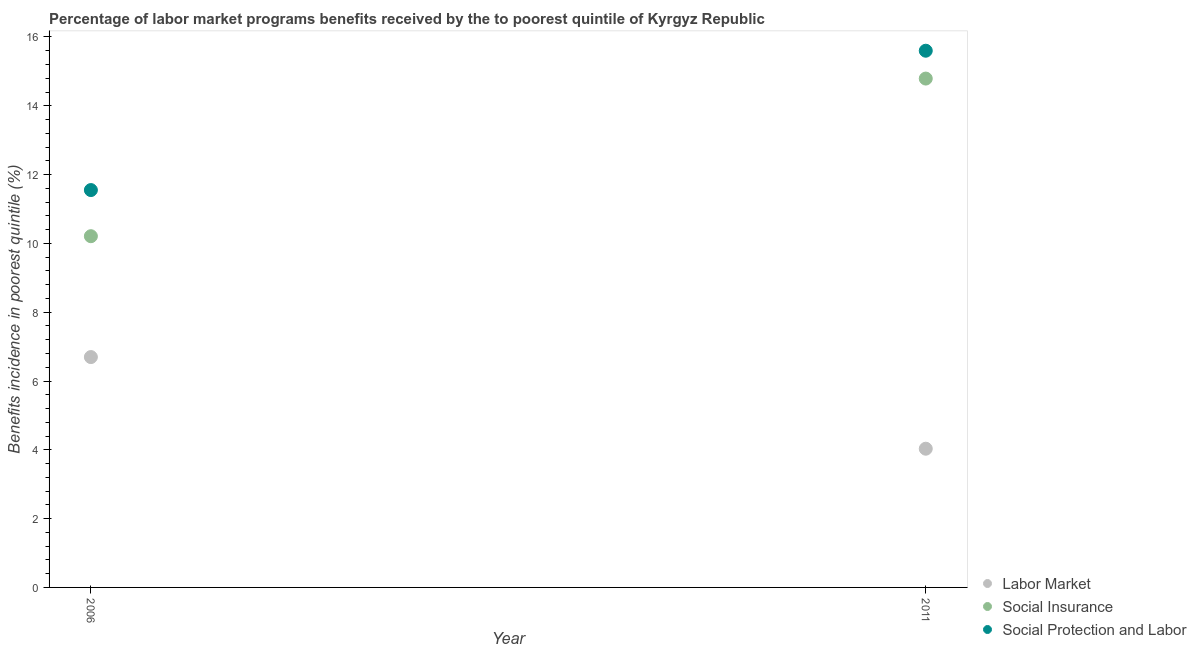What is the percentage of benefits received due to labor market programs in 2011?
Your response must be concise. 4.03. Across all years, what is the maximum percentage of benefits received due to social protection programs?
Offer a very short reply. 15.6. Across all years, what is the minimum percentage of benefits received due to labor market programs?
Make the answer very short. 4.03. In which year was the percentage of benefits received due to labor market programs maximum?
Make the answer very short. 2006. What is the total percentage of benefits received due to labor market programs in the graph?
Provide a succinct answer. 10.73. What is the difference between the percentage of benefits received due to labor market programs in 2006 and that in 2011?
Your response must be concise. 2.66. What is the difference between the percentage of benefits received due to social insurance programs in 2011 and the percentage of benefits received due to social protection programs in 2006?
Offer a very short reply. 3.24. What is the average percentage of benefits received due to labor market programs per year?
Keep it short and to the point. 5.36. In the year 2006, what is the difference between the percentage of benefits received due to labor market programs and percentage of benefits received due to social insurance programs?
Offer a terse response. -3.51. What is the ratio of the percentage of benefits received due to labor market programs in 2006 to that in 2011?
Provide a short and direct response. 1.66. Does the percentage of benefits received due to social insurance programs monotonically increase over the years?
Your response must be concise. Yes. Is the percentage of benefits received due to social insurance programs strictly greater than the percentage of benefits received due to social protection programs over the years?
Provide a short and direct response. No. Is the percentage of benefits received due to labor market programs strictly less than the percentage of benefits received due to social protection programs over the years?
Your response must be concise. Yes. How many dotlines are there?
Keep it short and to the point. 3. How many years are there in the graph?
Your response must be concise. 2. Are the values on the major ticks of Y-axis written in scientific E-notation?
Offer a very short reply. No. Does the graph contain any zero values?
Keep it short and to the point. No. Does the graph contain grids?
Offer a terse response. No. How many legend labels are there?
Your answer should be very brief. 3. What is the title of the graph?
Offer a terse response. Percentage of labor market programs benefits received by the to poorest quintile of Kyrgyz Republic. What is the label or title of the Y-axis?
Make the answer very short. Benefits incidence in poorest quintile (%). What is the Benefits incidence in poorest quintile (%) of Labor Market in 2006?
Make the answer very short. 6.7. What is the Benefits incidence in poorest quintile (%) of Social Insurance in 2006?
Your answer should be compact. 10.21. What is the Benefits incidence in poorest quintile (%) of Social Protection and Labor in 2006?
Provide a short and direct response. 11.55. What is the Benefits incidence in poorest quintile (%) of Labor Market in 2011?
Provide a short and direct response. 4.03. What is the Benefits incidence in poorest quintile (%) in Social Insurance in 2011?
Offer a terse response. 14.79. What is the Benefits incidence in poorest quintile (%) of Social Protection and Labor in 2011?
Give a very brief answer. 15.6. Across all years, what is the maximum Benefits incidence in poorest quintile (%) in Labor Market?
Keep it short and to the point. 6.7. Across all years, what is the maximum Benefits incidence in poorest quintile (%) of Social Insurance?
Make the answer very short. 14.79. Across all years, what is the maximum Benefits incidence in poorest quintile (%) in Social Protection and Labor?
Provide a succinct answer. 15.6. Across all years, what is the minimum Benefits incidence in poorest quintile (%) in Labor Market?
Your answer should be compact. 4.03. Across all years, what is the minimum Benefits incidence in poorest quintile (%) in Social Insurance?
Give a very brief answer. 10.21. Across all years, what is the minimum Benefits incidence in poorest quintile (%) in Social Protection and Labor?
Your answer should be compact. 11.55. What is the total Benefits incidence in poorest quintile (%) of Labor Market in the graph?
Provide a succinct answer. 10.73. What is the total Benefits incidence in poorest quintile (%) in Social Insurance in the graph?
Your answer should be very brief. 25. What is the total Benefits incidence in poorest quintile (%) in Social Protection and Labor in the graph?
Give a very brief answer. 27.15. What is the difference between the Benefits incidence in poorest quintile (%) in Labor Market in 2006 and that in 2011?
Provide a succinct answer. 2.66. What is the difference between the Benefits incidence in poorest quintile (%) in Social Insurance in 2006 and that in 2011?
Offer a very short reply. -4.58. What is the difference between the Benefits incidence in poorest quintile (%) of Social Protection and Labor in 2006 and that in 2011?
Your answer should be very brief. -4.05. What is the difference between the Benefits incidence in poorest quintile (%) of Labor Market in 2006 and the Benefits incidence in poorest quintile (%) of Social Insurance in 2011?
Your answer should be very brief. -8.09. What is the difference between the Benefits incidence in poorest quintile (%) in Labor Market in 2006 and the Benefits incidence in poorest quintile (%) in Social Protection and Labor in 2011?
Offer a very short reply. -8.9. What is the difference between the Benefits incidence in poorest quintile (%) of Social Insurance in 2006 and the Benefits incidence in poorest quintile (%) of Social Protection and Labor in 2011?
Offer a very short reply. -5.39. What is the average Benefits incidence in poorest quintile (%) of Labor Market per year?
Ensure brevity in your answer.  5.36. What is the average Benefits incidence in poorest quintile (%) in Social Insurance per year?
Give a very brief answer. 12.5. What is the average Benefits incidence in poorest quintile (%) in Social Protection and Labor per year?
Ensure brevity in your answer.  13.57. In the year 2006, what is the difference between the Benefits incidence in poorest quintile (%) in Labor Market and Benefits incidence in poorest quintile (%) in Social Insurance?
Offer a terse response. -3.51. In the year 2006, what is the difference between the Benefits incidence in poorest quintile (%) of Labor Market and Benefits incidence in poorest quintile (%) of Social Protection and Labor?
Offer a terse response. -4.85. In the year 2006, what is the difference between the Benefits incidence in poorest quintile (%) in Social Insurance and Benefits incidence in poorest quintile (%) in Social Protection and Labor?
Give a very brief answer. -1.34. In the year 2011, what is the difference between the Benefits incidence in poorest quintile (%) of Labor Market and Benefits incidence in poorest quintile (%) of Social Insurance?
Ensure brevity in your answer.  -10.76. In the year 2011, what is the difference between the Benefits incidence in poorest quintile (%) of Labor Market and Benefits incidence in poorest quintile (%) of Social Protection and Labor?
Ensure brevity in your answer.  -11.57. In the year 2011, what is the difference between the Benefits incidence in poorest quintile (%) in Social Insurance and Benefits incidence in poorest quintile (%) in Social Protection and Labor?
Provide a succinct answer. -0.81. What is the ratio of the Benefits incidence in poorest quintile (%) of Labor Market in 2006 to that in 2011?
Your response must be concise. 1.66. What is the ratio of the Benefits incidence in poorest quintile (%) in Social Insurance in 2006 to that in 2011?
Give a very brief answer. 0.69. What is the ratio of the Benefits incidence in poorest quintile (%) in Social Protection and Labor in 2006 to that in 2011?
Your response must be concise. 0.74. What is the difference between the highest and the second highest Benefits incidence in poorest quintile (%) in Labor Market?
Provide a succinct answer. 2.66. What is the difference between the highest and the second highest Benefits incidence in poorest quintile (%) in Social Insurance?
Keep it short and to the point. 4.58. What is the difference between the highest and the second highest Benefits incidence in poorest quintile (%) in Social Protection and Labor?
Offer a very short reply. 4.05. What is the difference between the highest and the lowest Benefits incidence in poorest quintile (%) of Labor Market?
Your response must be concise. 2.66. What is the difference between the highest and the lowest Benefits incidence in poorest quintile (%) of Social Insurance?
Your answer should be very brief. 4.58. What is the difference between the highest and the lowest Benefits incidence in poorest quintile (%) of Social Protection and Labor?
Provide a short and direct response. 4.05. 